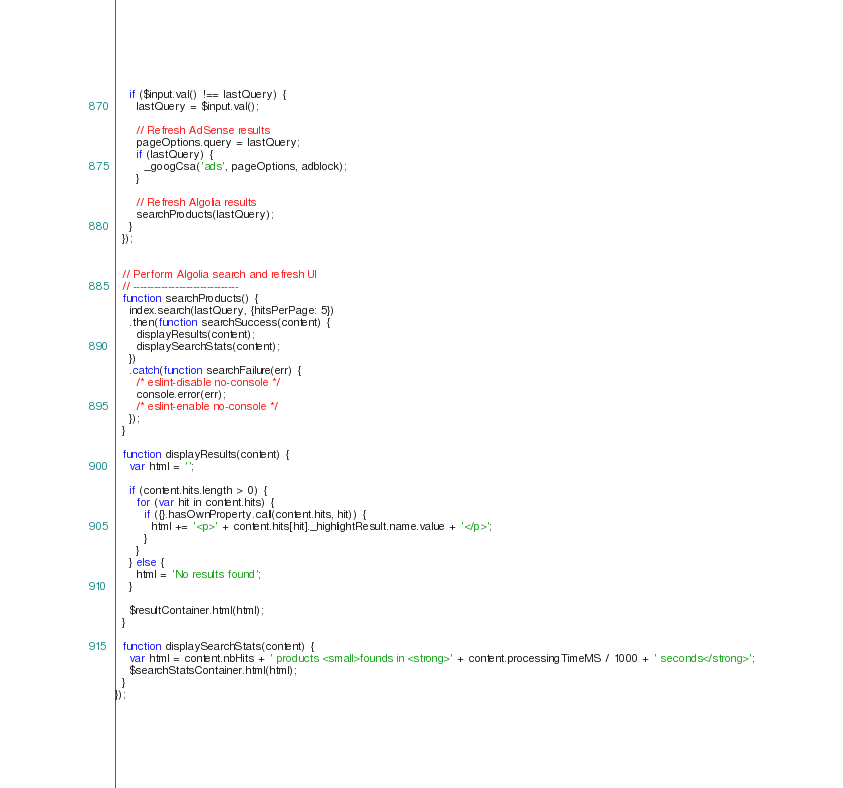<code> <loc_0><loc_0><loc_500><loc_500><_JavaScript_>
    if ($input.val() !== lastQuery) {
      lastQuery = $input.val();

      // Refresh AdSense results
      pageOptions.query = lastQuery;
      if (lastQuery) {
        _googCsa('ads', pageOptions, adblock);
      }

      // Refresh Algolia results
      searchProducts(lastQuery);
    }
  });


  // Perform Algolia search and refresh UI
  // ------------------------------
  function searchProducts() {
    index.search(lastQuery, {hitsPerPage: 5})
    .then(function searchSuccess(content) {
      displayResults(content);
      displaySearchStats(content);
    })
    .catch(function searchFailure(err) {
      /* eslint-disable no-console */
      console.error(err);
      /* eslint-enable no-console */
    });
  }

  function displayResults(content) {
    var html = '';

    if (content.hits.length > 0) {
      for (var hit in content.hits) {
        if ({}.hasOwnProperty.call(content.hits, hit)) {
          html += '<p>' + content.hits[hit]._highlightResult.name.value + '</p>';
        }
      }
    } else {
      html = 'No results found';
    }

    $resultContainer.html(html);
  }

  function displaySearchStats(content) {
    var html = content.nbHits + ' products <small>founds in <strong>' + content.processingTimeMS / 1000 + ' seconds</strong>';
    $searchStatsContainer.html(html);
  }
});
</code> 